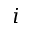Convert formula to latex. <formula><loc_0><loc_0><loc_500><loc_500>i</formula> 